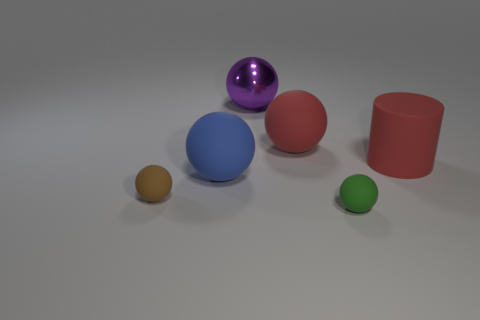Are there more large red spheres that are left of the shiny thing than tiny brown rubber balls on the left side of the tiny brown matte ball?
Offer a terse response. No. The rubber object that is both behind the small green rubber sphere and in front of the big blue object has what shape?
Provide a succinct answer. Sphere. There is a tiny matte object to the left of the large blue rubber thing; what shape is it?
Your answer should be compact. Sphere. How big is the red rubber thing that is to the right of the tiny matte thing in front of the tiny ball that is behind the tiny green object?
Ensure brevity in your answer.  Large. Do the blue rubber object and the tiny brown object have the same shape?
Your answer should be very brief. Yes. What is the size of the thing that is both left of the large purple metal ball and behind the brown matte ball?
Make the answer very short. Large. There is a big blue object that is the same shape as the small brown object; what is its material?
Give a very brief answer. Rubber. What material is the sphere in front of the small rubber ball that is to the left of the blue matte sphere?
Offer a terse response. Rubber. There is a blue object; is its shape the same as the big red thing that is right of the tiny green object?
Offer a very short reply. No. What number of rubber things are things or large purple objects?
Make the answer very short. 5. 